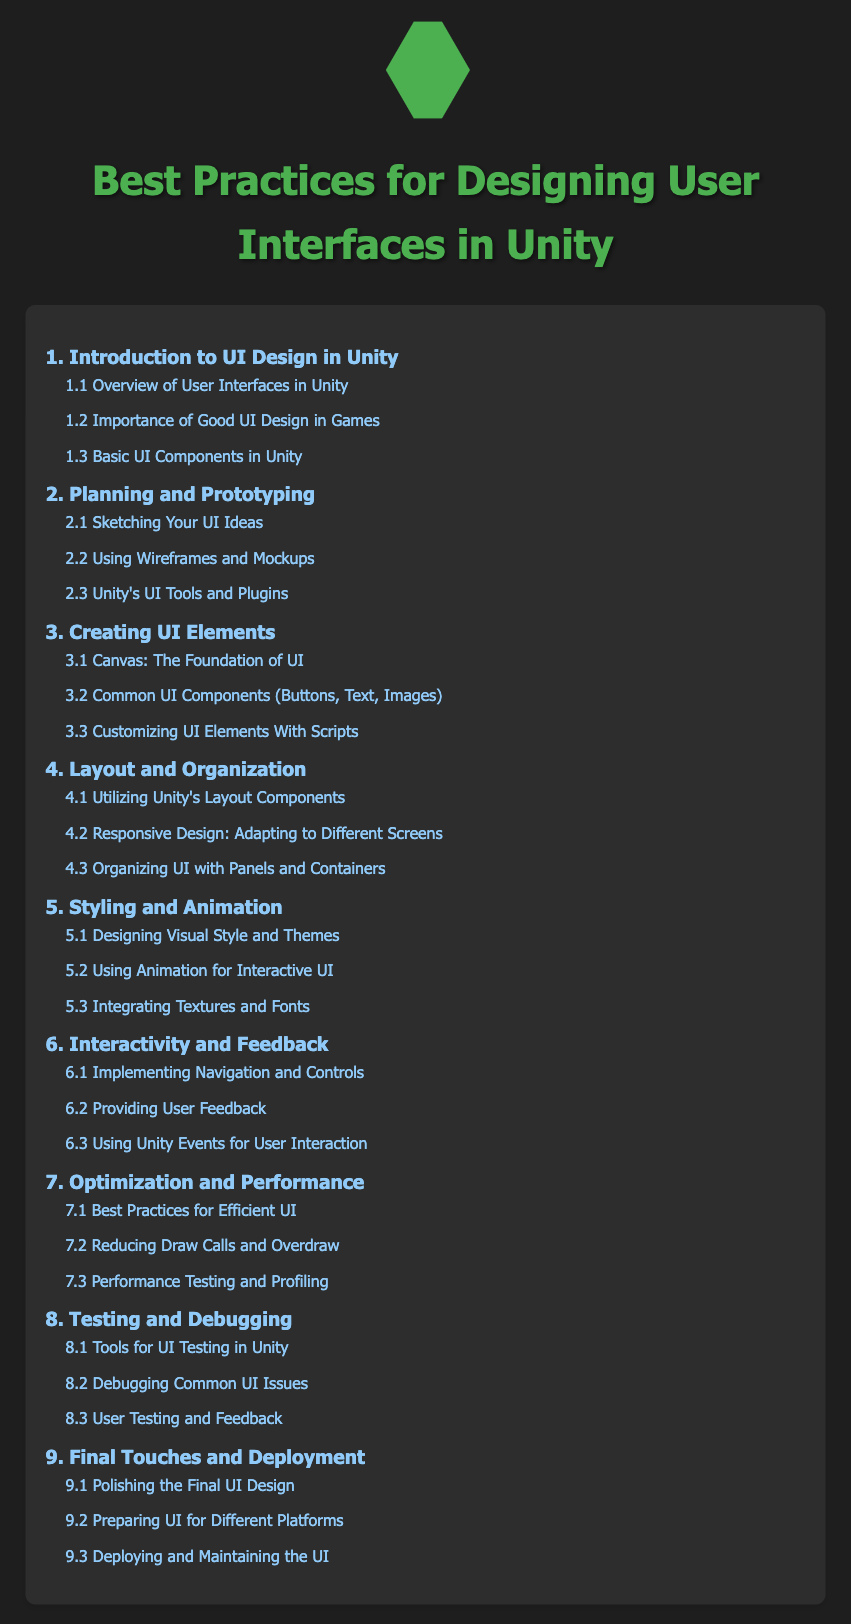what is the title of the document? The title of the document is provided at the top of the HTML and indicates the main focus of the content.
Answer: Best Practices for Designing User Interfaces in Unity how many main sections are listed in the table of contents? The number of main sections is determined by counting the top-level items in the list within the table of contents.
Answer: nine what is the first sub-section under "3. Creating UI Elements"? The order of sub-sections is indicated by numerical labels and lists under each main section heading.
Answer: Canvas: The Foundation of UI which section covers layout organization? The content organization assigns each section a specific focus, and layout organization is indicated with a specific title in the table of contents.
Answer: 4 what is the last main section in the document? The structure of the document allows us to identify the last main section title listed in the table of contents.
Answer: Final Touches and Deployment how many sub-sections are under the "7. Optimization and Performance" section? The count of sub-sections is indicated by the number of list items nested under the respective main section in the table of contents.
Answer: three what is the focus of section "6. Interactivity and Feedback"? The purpose of the main section is clear from its title, as it defines a specific area of UI design.
Answer: Interactivity and Feedback which sub-section provides information on user testing? The specific sub-section title mentions the context of user testing, indicated within the nested list under its main section.
Answer: User Testing and Feedback 